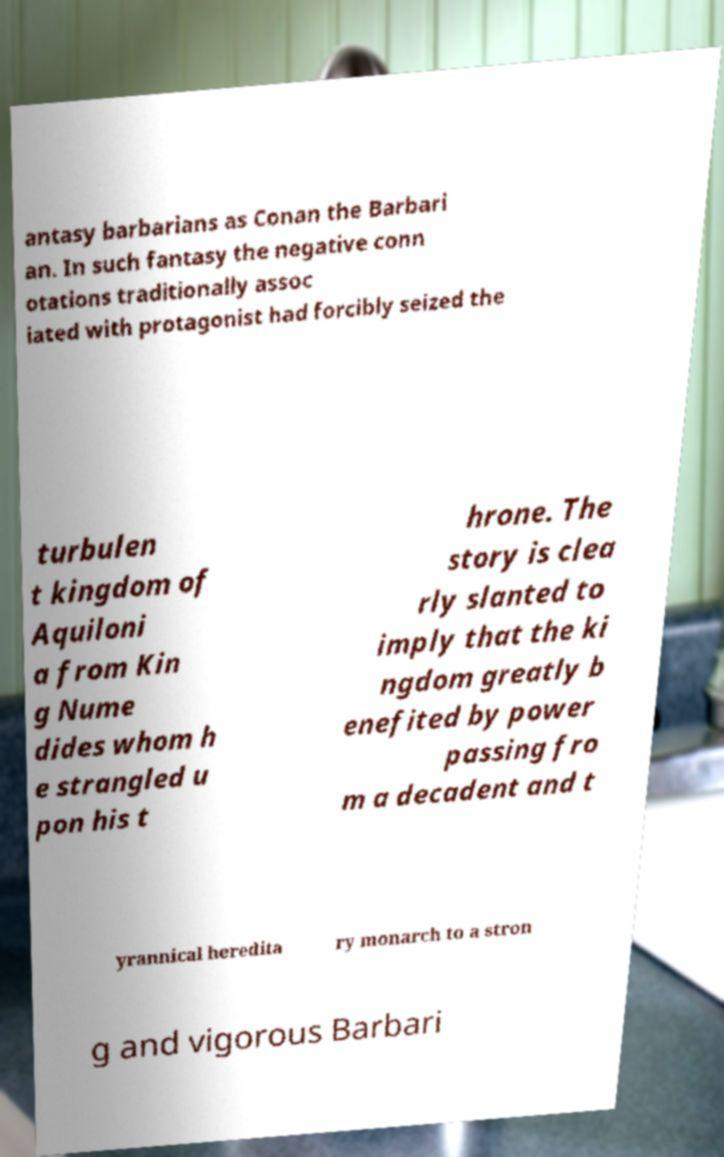Please read and relay the text visible in this image. What does it say? antasy barbarians as Conan the Barbari an. In such fantasy the negative conn otations traditionally assoc iated with protagonist had forcibly seized the turbulen t kingdom of Aquiloni a from Kin g Nume dides whom h e strangled u pon his t hrone. The story is clea rly slanted to imply that the ki ngdom greatly b enefited by power passing fro m a decadent and t yrannical heredita ry monarch to a stron g and vigorous Barbari 